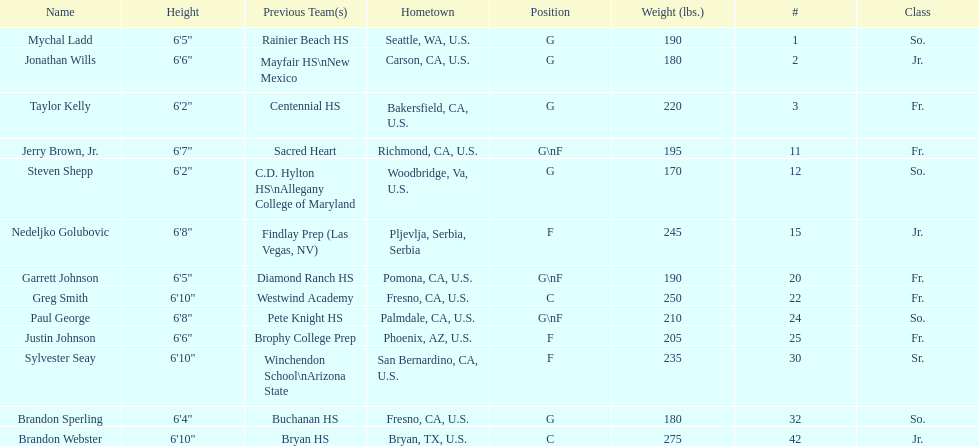Who is the next heaviest player after nedelijko golubovic? Sylvester Seay. 